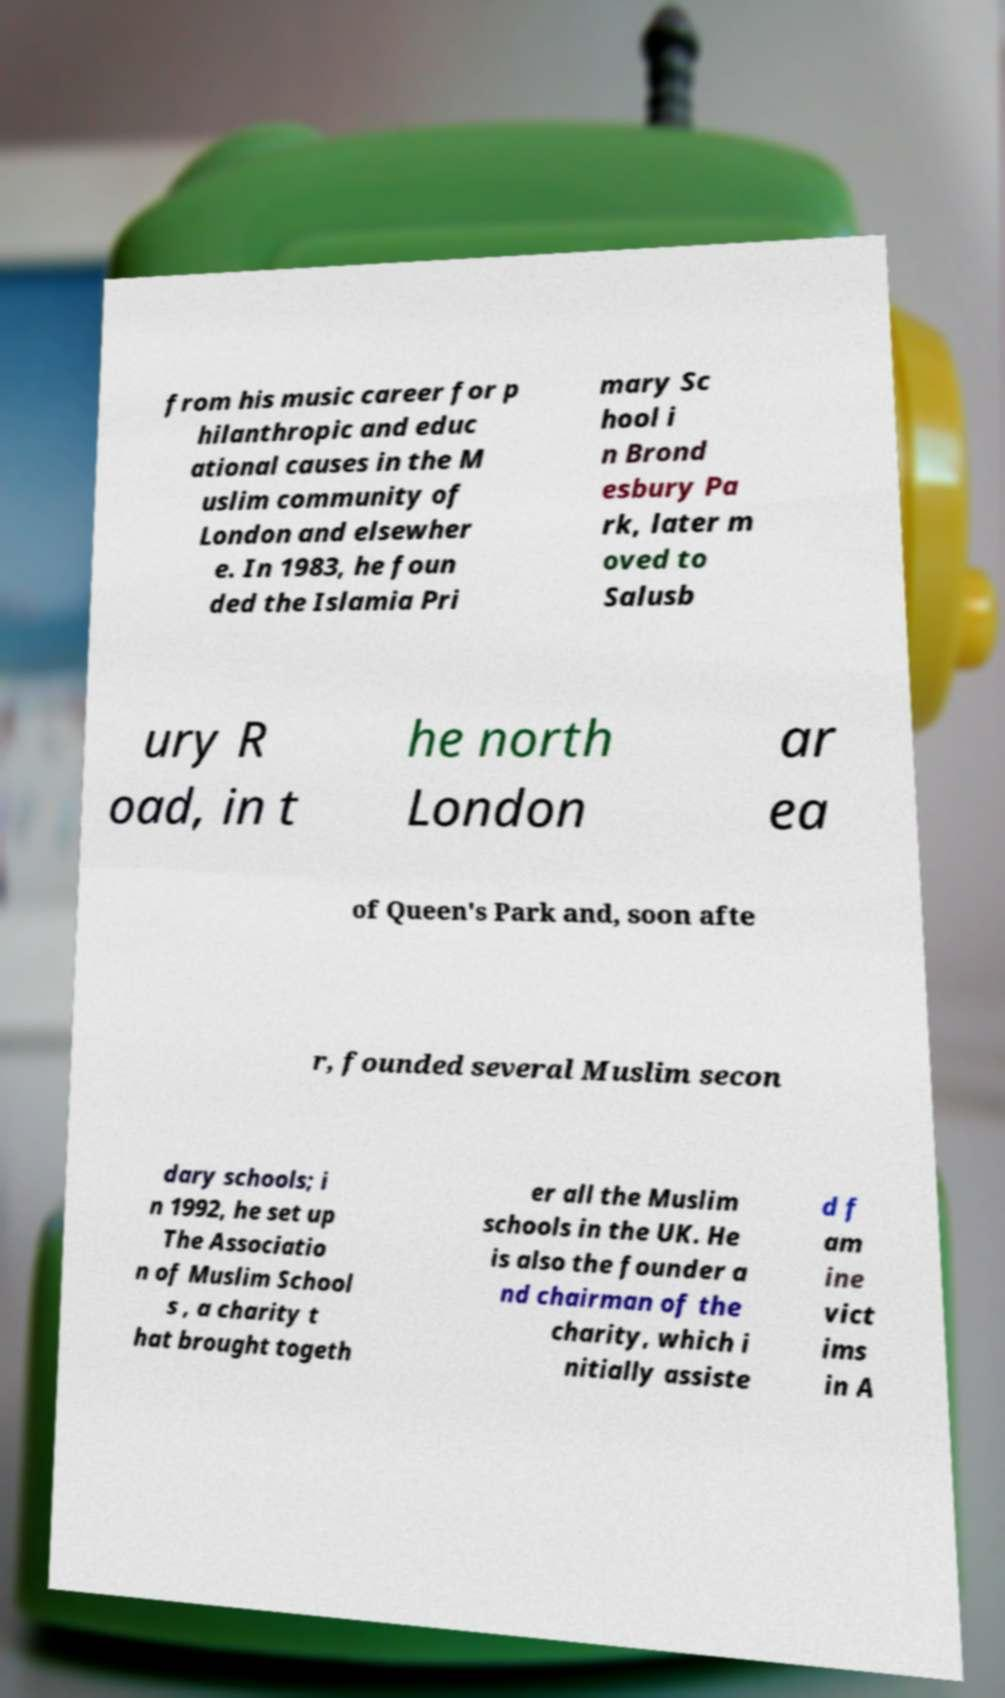I need the written content from this picture converted into text. Can you do that? from his music career for p hilanthropic and educ ational causes in the M uslim community of London and elsewher e. In 1983, he foun ded the Islamia Pri mary Sc hool i n Brond esbury Pa rk, later m oved to Salusb ury R oad, in t he north London ar ea of Queen's Park and, soon afte r, founded several Muslim secon dary schools; i n 1992, he set up The Associatio n of Muslim School s , a charity t hat brought togeth er all the Muslim schools in the UK. He is also the founder a nd chairman of the charity, which i nitially assiste d f am ine vict ims in A 